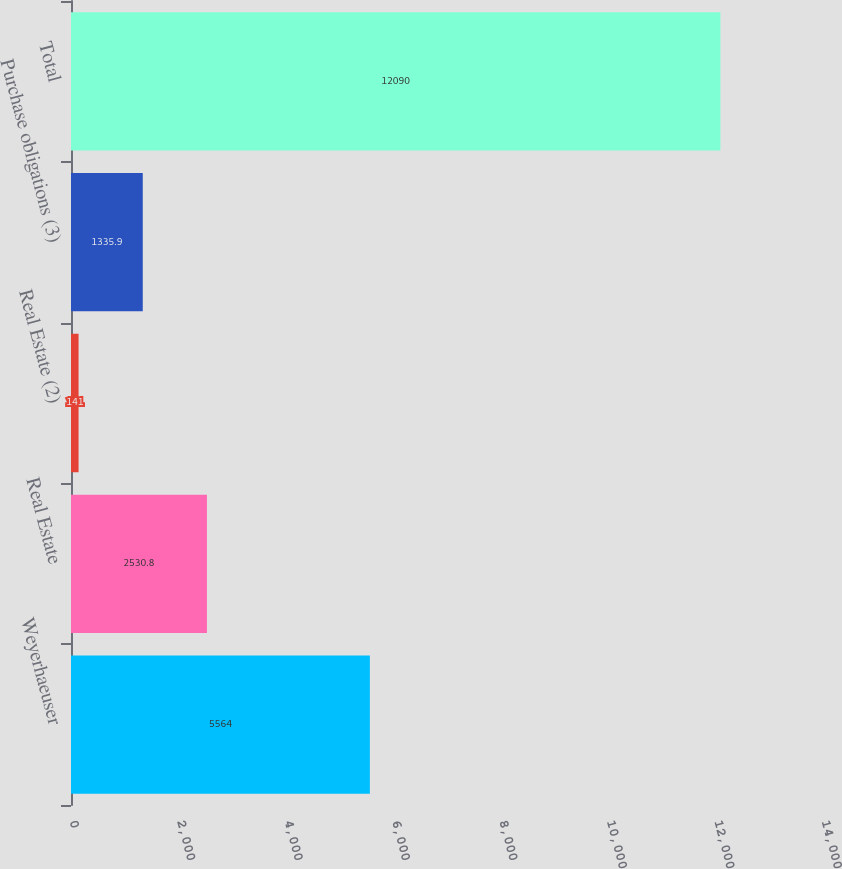<chart> <loc_0><loc_0><loc_500><loc_500><bar_chart><fcel>Weyerhaeuser<fcel>Real Estate<fcel>Real Estate (2)<fcel>Purchase obligations (3)<fcel>Total<nl><fcel>5564<fcel>2530.8<fcel>141<fcel>1335.9<fcel>12090<nl></chart> 